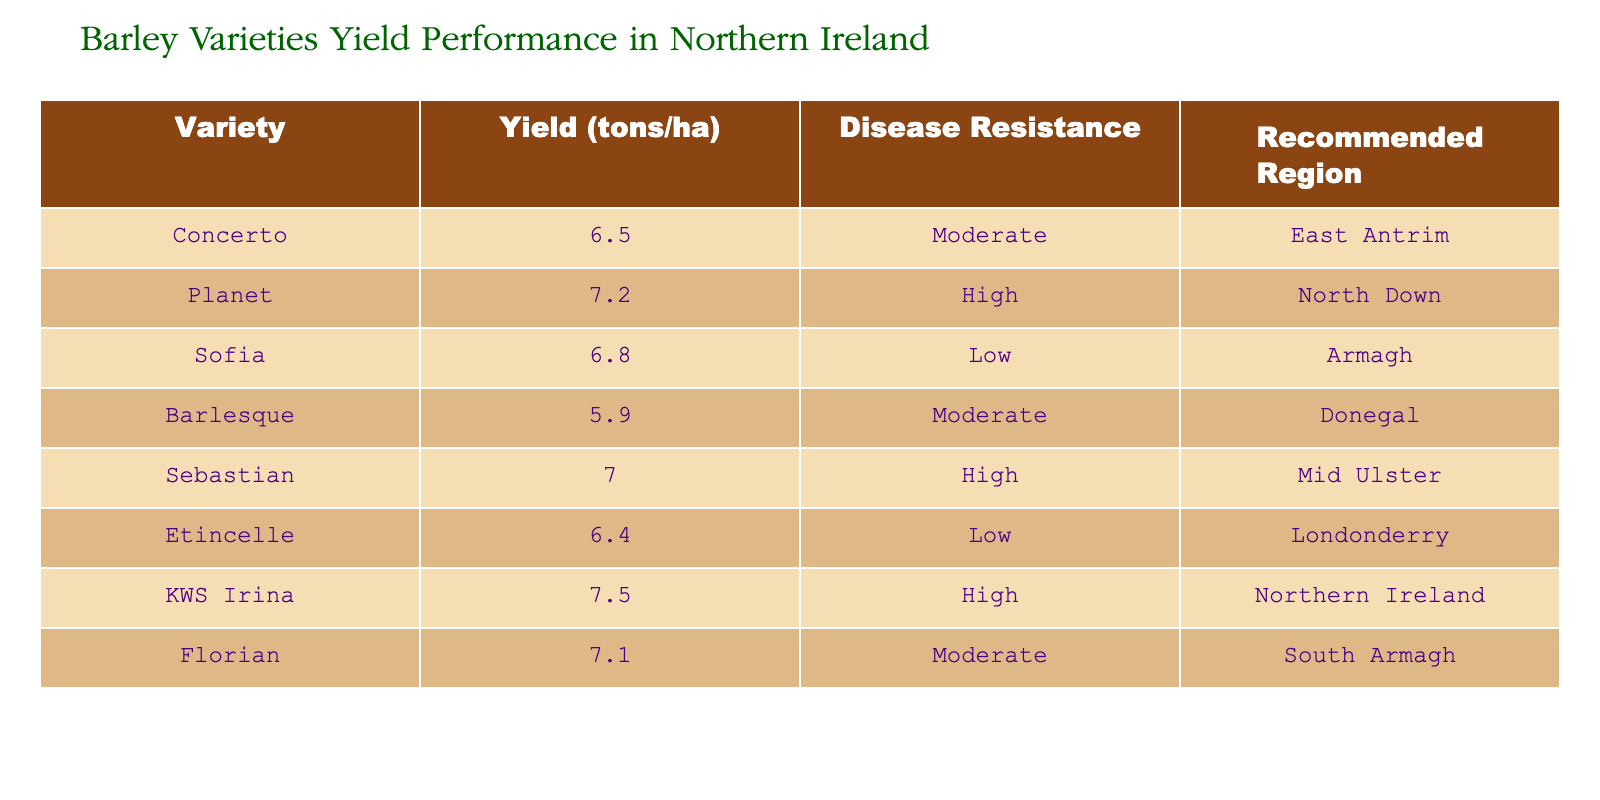What is the yield of KWS Irina? The yield of KWS Irina is explicitly listed in the table under the "Yield (tons/ha)" column. It states that KWS Irina produces 7.5 tons per hectare.
Answer: 7.5 tons/ha Which variety has the lowest yield? To find the lowest yield, I scanned down the "Yield (tons/ha)" column and identified the minimum value. The variety Barlesque has the lowest yield at 5.9 tons per hectare.
Answer: Barlesque How many varieties have high disease resistance? I counted the entries in the "Disease Resistance" column that are marked as "High." There are three varieties: Planet, Sebastian, and KWS Irina.
Answer: 3 What is the average yield of all barley varieties listed? To calculate the average yield: Add all yields together: (6.5 + 7.2 + 6.8 + 5.9 + 7.0 + 6.4 + 7.5 + 7.1) = 54, then divide by the number of varieties which is 8. The average yield is 54/8 = 6.75 tons/ha.
Answer: 6.75 tons/ha Is the Sofia variety recommended for the East Antrim region? By checking the "Recommended Region" for Sofia in the table, it is listed as "Armagh," not "East Antrim." Therefore, the statement is false.
Answer: No Which variety has the highest yield and is also recommended for the entire Northern Ireland? I looked for the maximum yield in the "Yield (tons/ha)" column and checked the corresponding "Recommended Region." KWS Irina has the highest yield (7.5 tons/ha) and is recommended for "Northern Ireland."
Answer: KWS Irina What is the difference in yield between the highest and lowest yielding barley varieties? The highest yield is from KWS Irina (7.5 tons/ha) and the lowest yield is from Barlesque (5.9 tons/ha). The difference can be calculated as 7.5 - 5.9 = 1.6 tons/ha.
Answer: 1.6 tons/ha Are there any varieties recommended for Donegal? I looked at the "Recommended Region" column and found that Barlesque is the only variety listed for Donegal, confirming that there is at least one.
Answer: Yes 